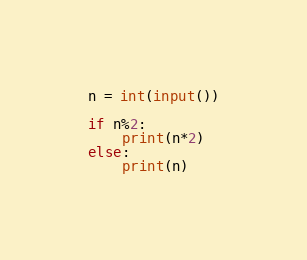Convert code to text. <code><loc_0><loc_0><loc_500><loc_500><_Python_>n = int(input())

if n%2:
    print(n*2)
else:
    print(n)</code> 